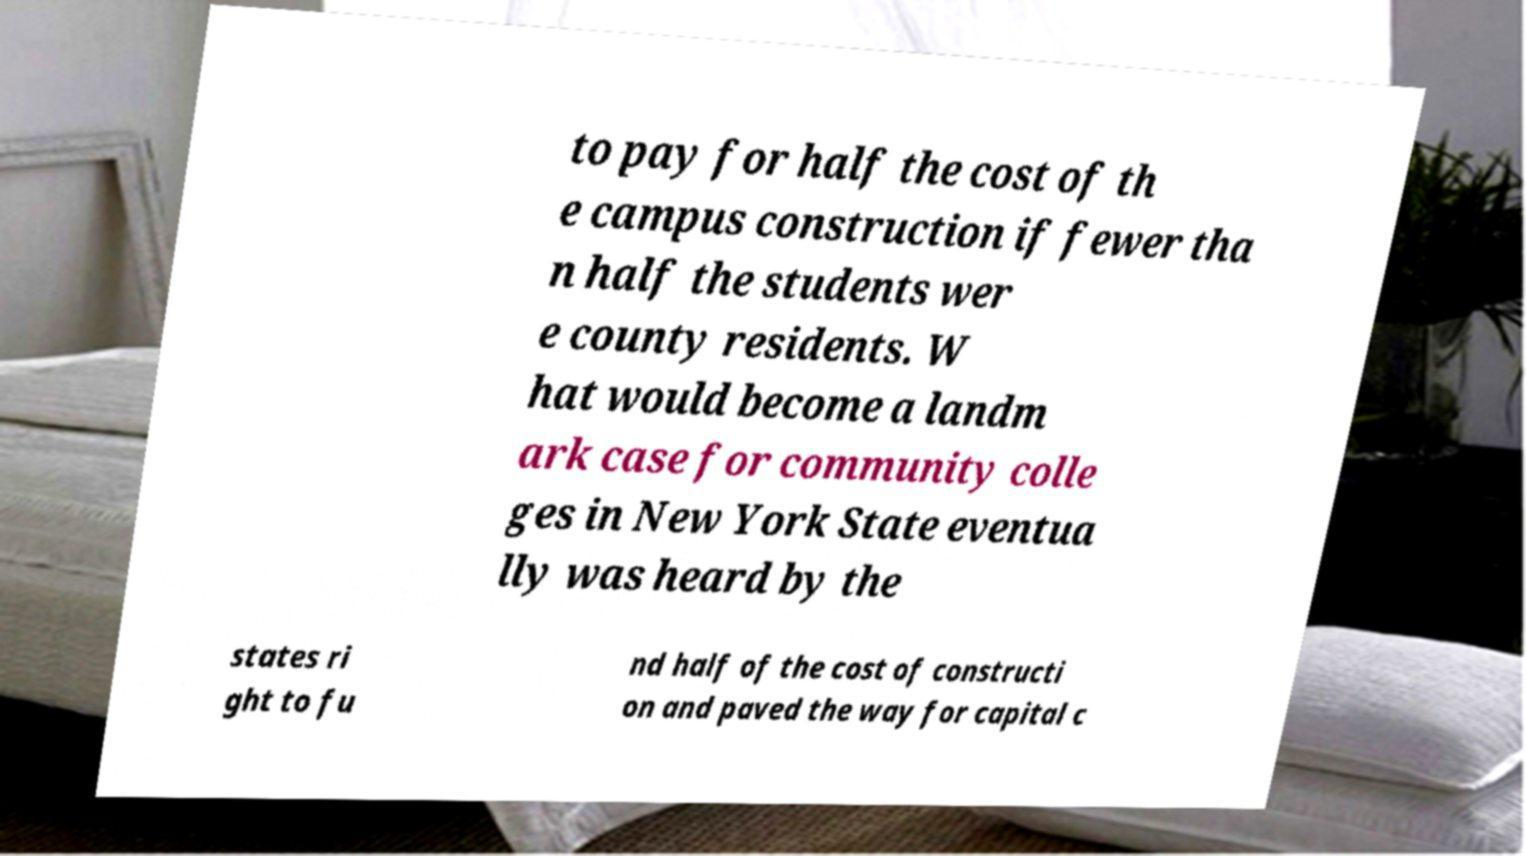What messages or text are displayed in this image? I need them in a readable, typed format. to pay for half the cost of th e campus construction if fewer tha n half the students wer e county residents. W hat would become a landm ark case for community colle ges in New York State eventua lly was heard by the states ri ght to fu nd half of the cost of constructi on and paved the way for capital c 